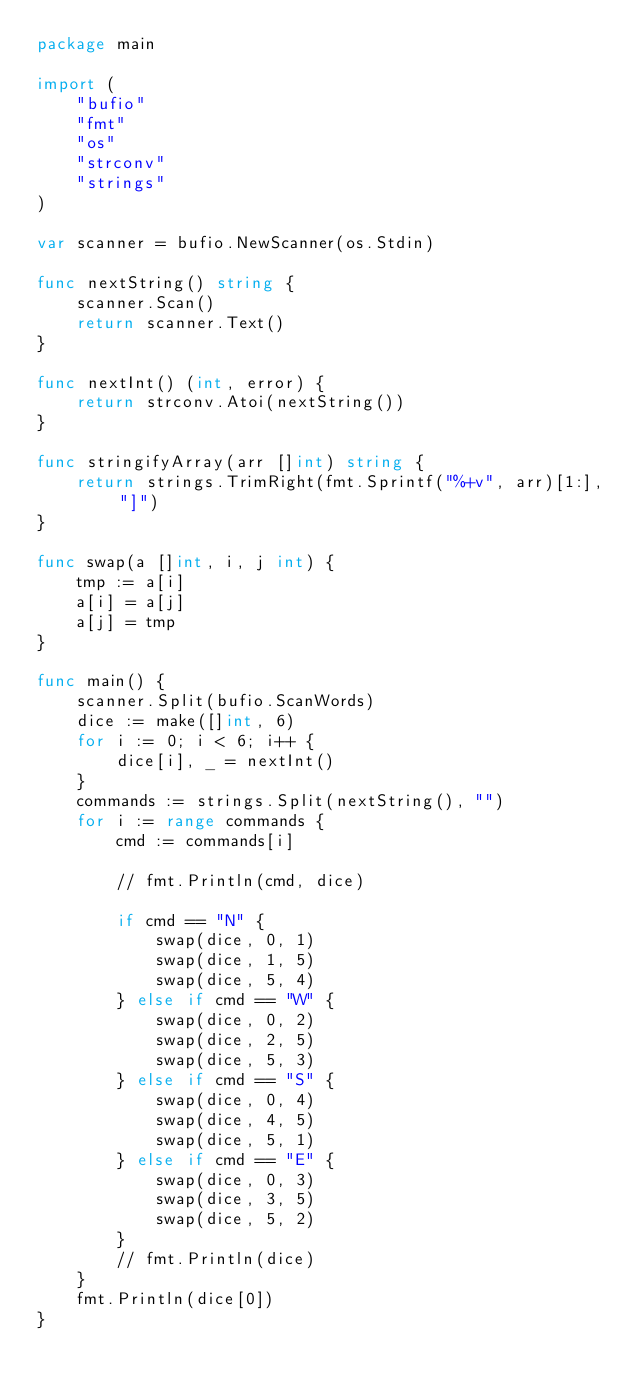<code> <loc_0><loc_0><loc_500><loc_500><_Go_>package main

import (
	"bufio"
	"fmt"
	"os"
	"strconv"
	"strings"
)

var scanner = bufio.NewScanner(os.Stdin)

func nextString() string {
	scanner.Scan()
	return scanner.Text()
}

func nextInt() (int, error) {
	return strconv.Atoi(nextString())
}

func stringifyArray(arr []int) string {
	return strings.TrimRight(fmt.Sprintf("%+v", arr)[1:], "]")
}

func swap(a []int, i, j int) {
	tmp := a[i]
	a[i] = a[j]
	a[j] = tmp
}

func main() {
	scanner.Split(bufio.ScanWords)
	dice := make([]int, 6)
	for i := 0; i < 6; i++ {
		dice[i], _ = nextInt()
	}
	commands := strings.Split(nextString(), "")
	for i := range commands {
		cmd := commands[i]

		// fmt.Println(cmd, dice)

		if cmd == "N" {
			swap(dice, 0, 1)
			swap(dice, 1, 5)
			swap(dice, 5, 4)
		} else if cmd == "W" {
			swap(dice, 0, 2)
			swap(dice, 2, 5)
			swap(dice, 5, 3)
		} else if cmd == "S" {
			swap(dice, 0, 4)
			swap(dice, 4, 5)
			swap(dice, 5, 1)
		} else if cmd == "E" {
			swap(dice, 0, 3)
			swap(dice, 3, 5)
			swap(dice, 5, 2)
		}
		// fmt.Println(dice)
	}
	fmt.Println(dice[0])
}

</code> 